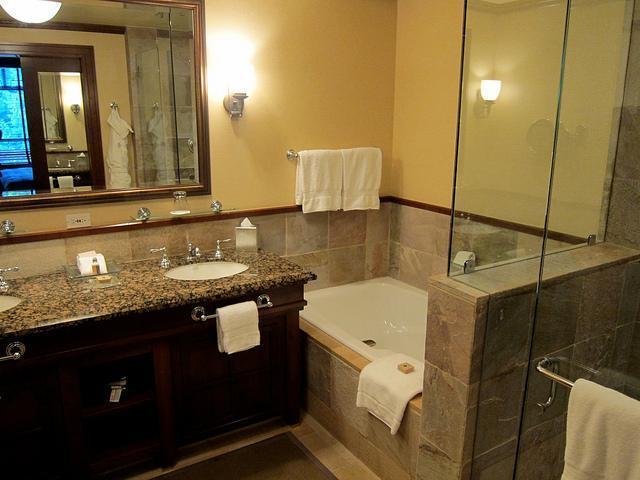How many lights fixtures are there?
Give a very brief answer. 2. How many cars on the locomotive have unprotected wheels?
Give a very brief answer. 0. 